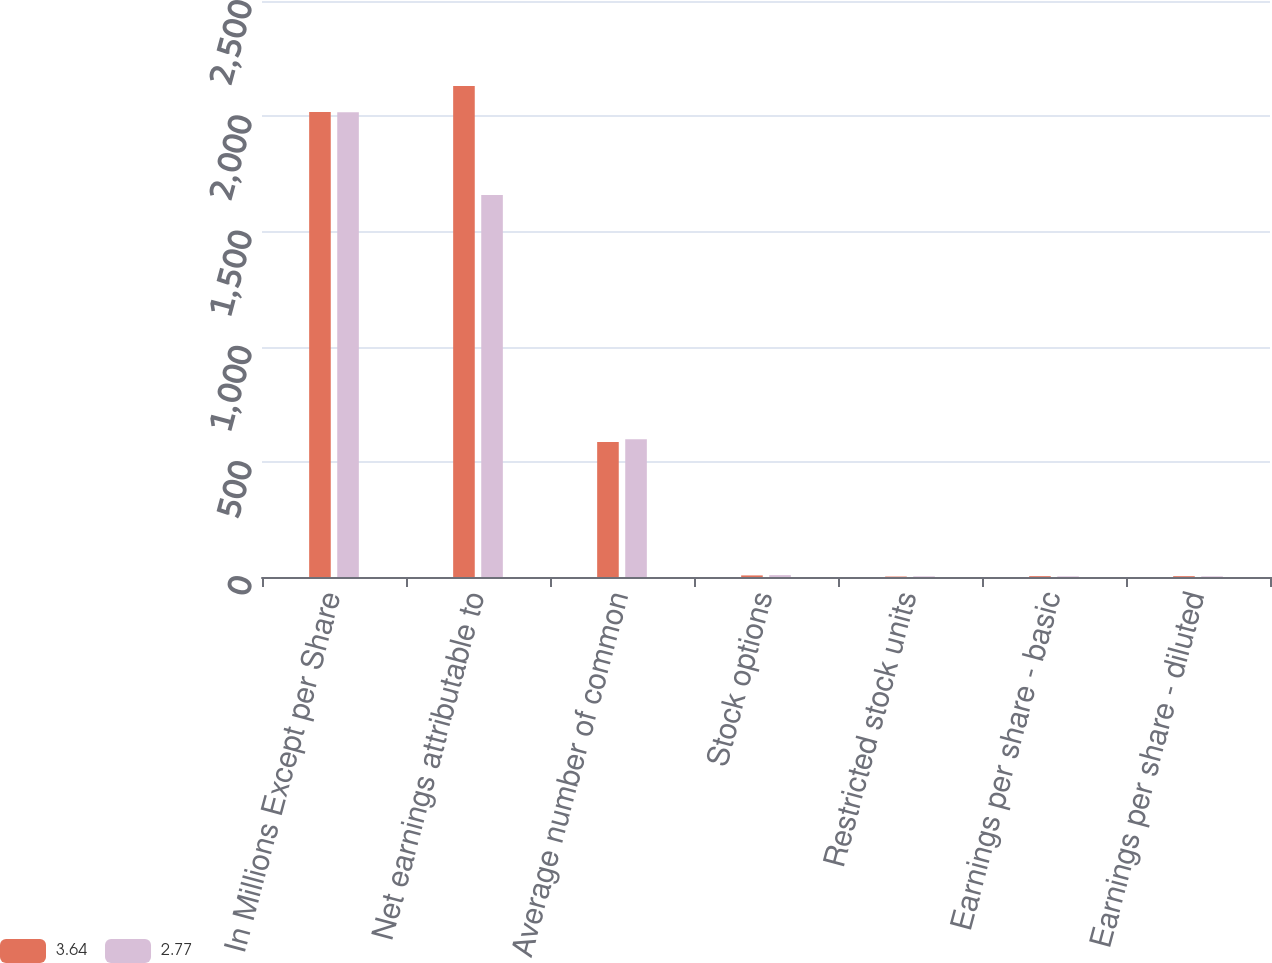Convert chart. <chart><loc_0><loc_0><loc_500><loc_500><stacked_bar_chart><ecel><fcel>In Millions Except per Share<fcel>Net earnings attributable to<fcel>Average number of common<fcel>Stock options<fcel>Restricted stock units<fcel>Earnings per share - basic<fcel>Earnings per share - diluted<nl><fcel>3.64<fcel>2018<fcel>2131<fcel>585.7<fcel>6.9<fcel>2<fcel>3.69<fcel>3.64<nl><fcel>2.77<fcel>2017<fcel>1657.5<fcel>598<fcel>8.1<fcel>2.8<fcel>2.82<fcel>2.77<nl></chart> 